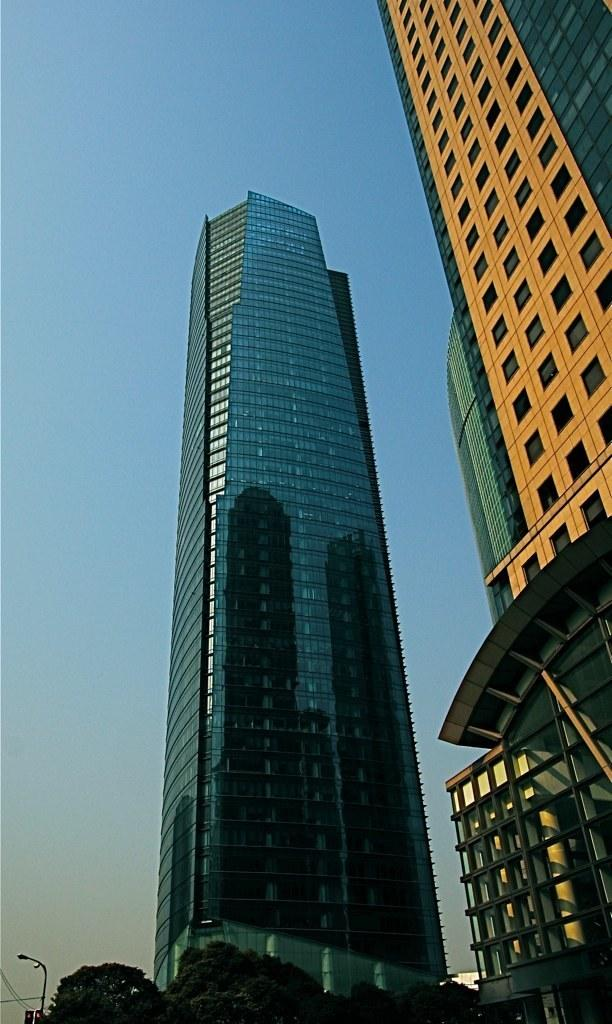What type of structures are located in the center of the image? Buildings are present in the center of the image. What type of vegetation can be seen at the bottom of the image? Trees are visible at the bottom of the image. What is attached to the electric light pole at the bottom of the image? Wires are present at the bottom of the image. What can be seen in the background of the image? The sky is visible in the background of the image. Who is the owner of the industry depicted in the image? There is no industry depicted in the image, so it is not possible to determine the owner. How does the sleep of the trees affect the buildings in the image? There is no information about the trees sleeping, and the buildings are not affected by any such activity. 